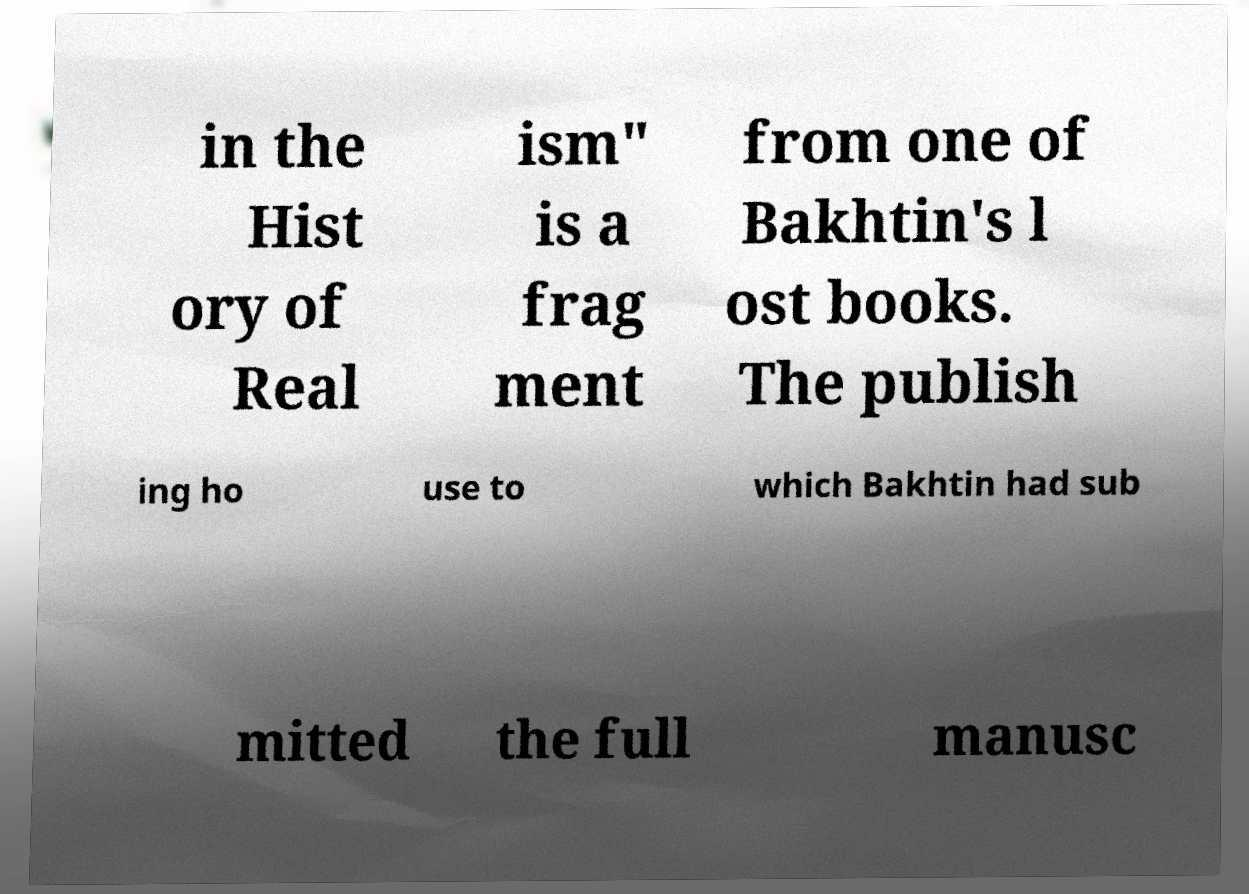Please identify and transcribe the text found in this image. in the Hist ory of Real ism" is a frag ment from one of Bakhtin's l ost books. The publish ing ho use to which Bakhtin had sub mitted the full manusc 